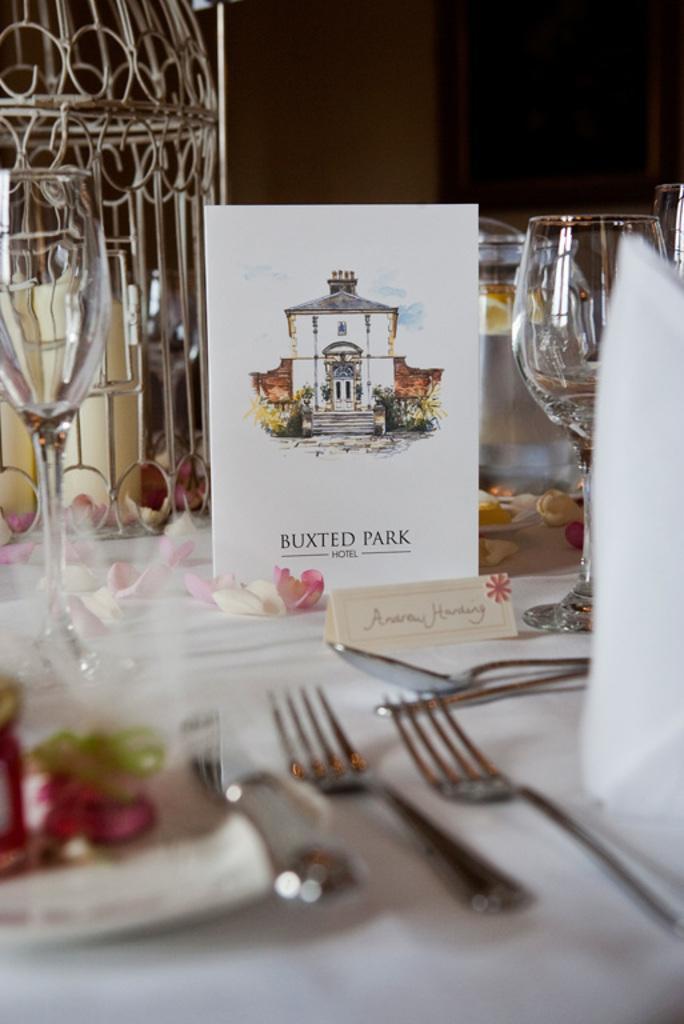In one or two sentences, can you explain what this image depicts? In this picture we can see a table, there are forks, spoons, glasses, a car, petals of flower and tissue papers present on the table, we can see a dark background. 